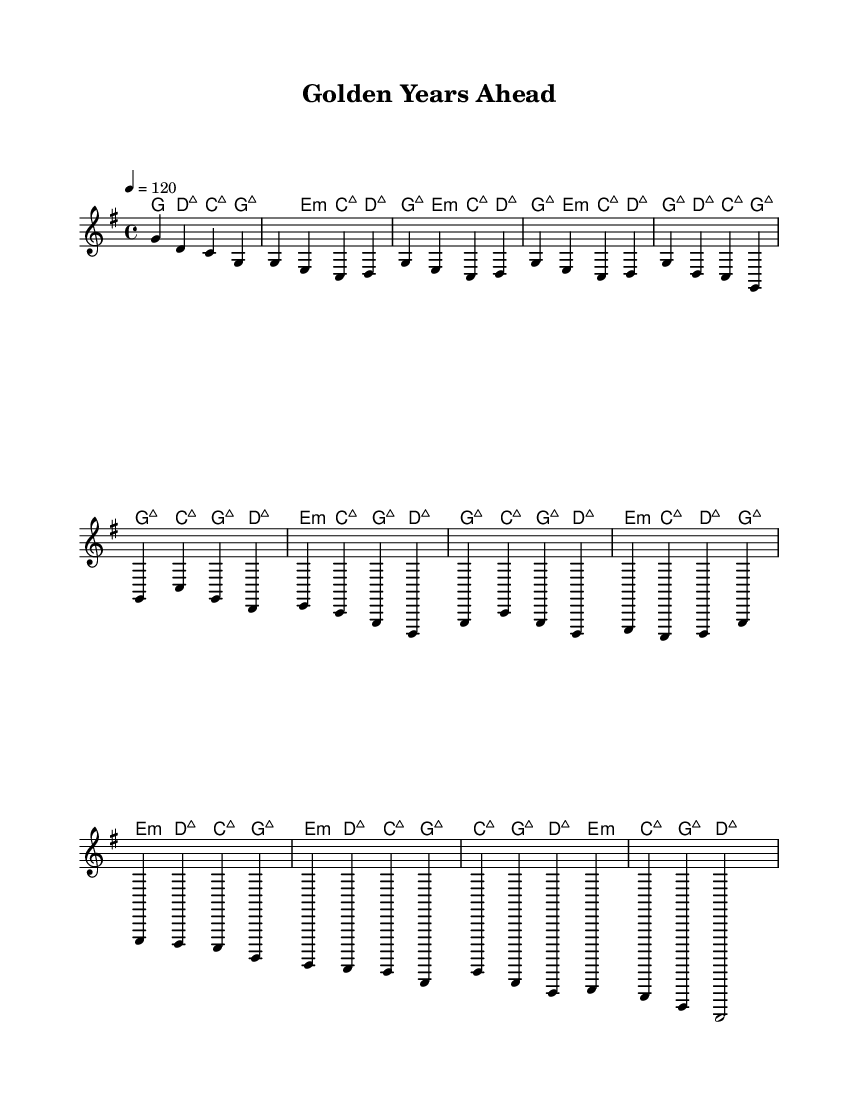What is the key signature of this music? The key signature appears at the beginning of the sheet music, indicating it is G major, which has one sharp (F#).
Answer: G major What is the time signature of this music? The time signature, found at the beginning of the piece, is indicated as 4/4, which means there are four beats in each measure and each quarter note gets one beat.
Answer: 4/4 What is the tempo marking for this music? The tempo marking is found at the beginning of the score, set to 120 beats per minute, indicating how fast the music should be played.
Answer: 120 How many measures are in the chorus section? By analyzing the section where the chorus occurs, we count four measures, indicating the structure of this part of the music.
Answer: 4 What chord does the music begin with? The music starts with a G major chord, which is the first chord indicated in the harmonies portion.
Answer: G major What section follows the verse? The structure of the music shows that after the verse section, the chorus follows, making this a common progression in music composition.
Answer: Chorus What is the overall mood of this piece? The upbeat tempo combined with major chords and themes of celebration points to a joyful and lively mood throughout the song.
Answer: Joyful 